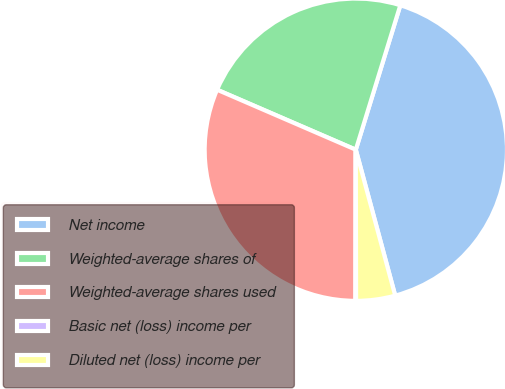Convert chart. <chart><loc_0><loc_0><loc_500><loc_500><pie_chart><fcel>Net income<fcel>Weighted-average shares of<fcel>Weighted-average shares used<fcel>Basic net (loss) income per<fcel>Diluted net (loss) income per<nl><fcel>41.04%<fcel>23.26%<fcel>31.45%<fcel>0.07%<fcel>4.17%<nl></chart> 